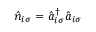<formula> <loc_0><loc_0><loc_500><loc_500>\hat { n } _ { i \sigma } = \hat { a } _ { i \sigma } ^ { \dagger } \hat { a } _ { i \sigma }</formula> 